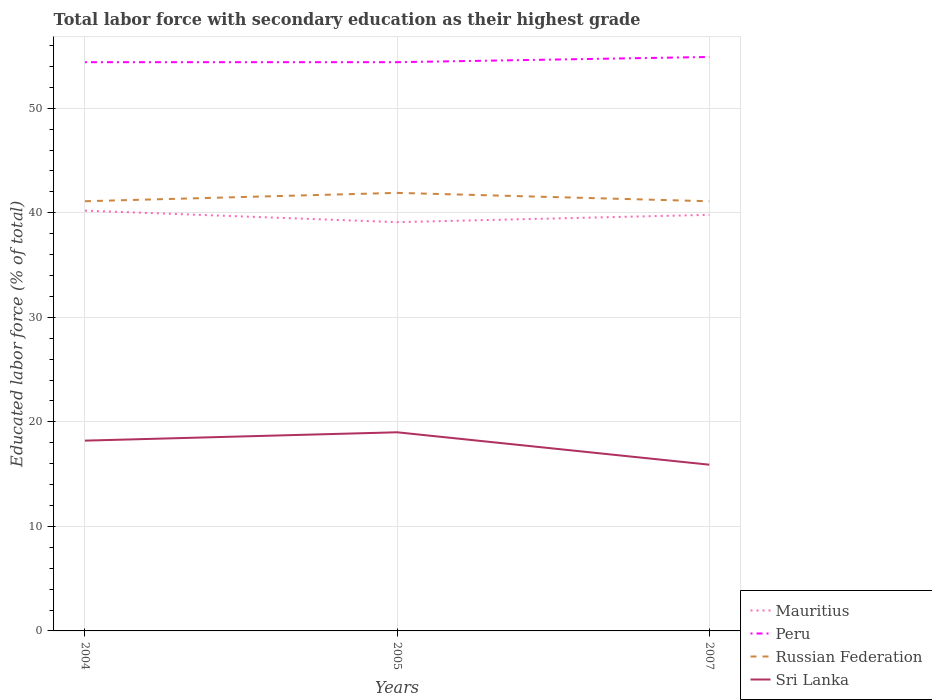Across all years, what is the maximum percentage of total labor force with primary education in Mauritius?
Your response must be concise. 39.1. In which year was the percentage of total labor force with primary education in Sri Lanka maximum?
Give a very brief answer. 2007. What is the total percentage of total labor force with primary education in Mauritius in the graph?
Your answer should be compact. 1.1. What is the difference between the highest and the second highest percentage of total labor force with primary education in Peru?
Your answer should be very brief. 0.5. What is the difference between the highest and the lowest percentage of total labor force with primary education in Peru?
Provide a short and direct response. 1. How many years are there in the graph?
Provide a succinct answer. 3. What is the difference between two consecutive major ticks on the Y-axis?
Offer a terse response. 10. Does the graph contain any zero values?
Give a very brief answer. No. How are the legend labels stacked?
Provide a short and direct response. Vertical. What is the title of the graph?
Provide a short and direct response. Total labor force with secondary education as their highest grade. What is the label or title of the X-axis?
Your answer should be compact. Years. What is the label or title of the Y-axis?
Your response must be concise. Educated labor force (% of total). What is the Educated labor force (% of total) of Mauritius in 2004?
Your response must be concise. 40.2. What is the Educated labor force (% of total) of Peru in 2004?
Your answer should be very brief. 54.4. What is the Educated labor force (% of total) of Russian Federation in 2004?
Give a very brief answer. 41.1. What is the Educated labor force (% of total) in Sri Lanka in 2004?
Provide a succinct answer. 18.2. What is the Educated labor force (% of total) of Mauritius in 2005?
Your response must be concise. 39.1. What is the Educated labor force (% of total) in Peru in 2005?
Your answer should be compact. 54.4. What is the Educated labor force (% of total) of Russian Federation in 2005?
Your answer should be very brief. 41.9. What is the Educated labor force (% of total) of Mauritius in 2007?
Make the answer very short. 39.8. What is the Educated labor force (% of total) of Peru in 2007?
Your response must be concise. 54.9. What is the Educated labor force (% of total) in Russian Federation in 2007?
Ensure brevity in your answer.  41.1. What is the Educated labor force (% of total) of Sri Lanka in 2007?
Offer a terse response. 15.9. Across all years, what is the maximum Educated labor force (% of total) of Mauritius?
Give a very brief answer. 40.2. Across all years, what is the maximum Educated labor force (% of total) of Peru?
Provide a succinct answer. 54.9. Across all years, what is the maximum Educated labor force (% of total) in Russian Federation?
Ensure brevity in your answer.  41.9. Across all years, what is the maximum Educated labor force (% of total) of Sri Lanka?
Your response must be concise. 19. Across all years, what is the minimum Educated labor force (% of total) of Mauritius?
Offer a terse response. 39.1. Across all years, what is the minimum Educated labor force (% of total) of Peru?
Provide a succinct answer. 54.4. Across all years, what is the minimum Educated labor force (% of total) of Russian Federation?
Ensure brevity in your answer.  41.1. Across all years, what is the minimum Educated labor force (% of total) in Sri Lanka?
Provide a succinct answer. 15.9. What is the total Educated labor force (% of total) of Mauritius in the graph?
Your answer should be compact. 119.1. What is the total Educated labor force (% of total) of Peru in the graph?
Your answer should be compact. 163.7. What is the total Educated labor force (% of total) of Russian Federation in the graph?
Provide a succinct answer. 124.1. What is the total Educated labor force (% of total) of Sri Lanka in the graph?
Your answer should be compact. 53.1. What is the difference between the Educated labor force (% of total) in Mauritius in 2004 and that in 2005?
Your response must be concise. 1.1. What is the difference between the Educated labor force (% of total) in Peru in 2004 and that in 2005?
Your answer should be compact. 0. What is the difference between the Educated labor force (% of total) of Sri Lanka in 2004 and that in 2005?
Your answer should be compact. -0.8. What is the difference between the Educated labor force (% of total) in Mauritius in 2005 and that in 2007?
Your answer should be compact. -0.7. What is the difference between the Educated labor force (% of total) in Sri Lanka in 2005 and that in 2007?
Your answer should be very brief. 3.1. What is the difference between the Educated labor force (% of total) of Mauritius in 2004 and the Educated labor force (% of total) of Sri Lanka in 2005?
Your answer should be very brief. 21.2. What is the difference between the Educated labor force (% of total) in Peru in 2004 and the Educated labor force (% of total) in Russian Federation in 2005?
Give a very brief answer. 12.5. What is the difference between the Educated labor force (% of total) of Peru in 2004 and the Educated labor force (% of total) of Sri Lanka in 2005?
Your response must be concise. 35.4. What is the difference between the Educated labor force (% of total) of Russian Federation in 2004 and the Educated labor force (% of total) of Sri Lanka in 2005?
Offer a terse response. 22.1. What is the difference between the Educated labor force (% of total) in Mauritius in 2004 and the Educated labor force (% of total) in Peru in 2007?
Ensure brevity in your answer.  -14.7. What is the difference between the Educated labor force (% of total) of Mauritius in 2004 and the Educated labor force (% of total) of Russian Federation in 2007?
Give a very brief answer. -0.9. What is the difference between the Educated labor force (% of total) in Mauritius in 2004 and the Educated labor force (% of total) in Sri Lanka in 2007?
Provide a short and direct response. 24.3. What is the difference between the Educated labor force (% of total) of Peru in 2004 and the Educated labor force (% of total) of Russian Federation in 2007?
Provide a succinct answer. 13.3. What is the difference between the Educated labor force (% of total) in Peru in 2004 and the Educated labor force (% of total) in Sri Lanka in 2007?
Your answer should be compact. 38.5. What is the difference between the Educated labor force (% of total) of Russian Federation in 2004 and the Educated labor force (% of total) of Sri Lanka in 2007?
Offer a very short reply. 25.2. What is the difference between the Educated labor force (% of total) of Mauritius in 2005 and the Educated labor force (% of total) of Peru in 2007?
Provide a succinct answer. -15.8. What is the difference between the Educated labor force (% of total) in Mauritius in 2005 and the Educated labor force (% of total) in Sri Lanka in 2007?
Provide a succinct answer. 23.2. What is the difference between the Educated labor force (% of total) in Peru in 2005 and the Educated labor force (% of total) in Sri Lanka in 2007?
Your response must be concise. 38.5. What is the average Educated labor force (% of total) of Mauritius per year?
Your answer should be compact. 39.7. What is the average Educated labor force (% of total) in Peru per year?
Make the answer very short. 54.57. What is the average Educated labor force (% of total) in Russian Federation per year?
Offer a terse response. 41.37. What is the average Educated labor force (% of total) in Sri Lanka per year?
Your response must be concise. 17.7. In the year 2004, what is the difference between the Educated labor force (% of total) in Mauritius and Educated labor force (% of total) in Peru?
Provide a short and direct response. -14.2. In the year 2004, what is the difference between the Educated labor force (% of total) in Peru and Educated labor force (% of total) in Russian Federation?
Ensure brevity in your answer.  13.3. In the year 2004, what is the difference between the Educated labor force (% of total) of Peru and Educated labor force (% of total) of Sri Lanka?
Keep it short and to the point. 36.2. In the year 2004, what is the difference between the Educated labor force (% of total) of Russian Federation and Educated labor force (% of total) of Sri Lanka?
Ensure brevity in your answer.  22.9. In the year 2005, what is the difference between the Educated labor force (% of total) in Mauritius and Educated labor force (% of total) in Peru?
Your answer should be compact. -15.3. In the year 2005, what is the difference between the Educated labor force (% of total) in Mauritius and Educated labor force (% of total) in Russian Federation?
Give a very brief answer. -2.8. In the year 2005, what is the difference between the Educated labor force (% of total) of Mauritius and Educated labor force (% of total) of Sri Lanka?
Provide a short and direct response. 20.1. In the year 2005, what is the difference between the Educated labor force (% of total) of Peru and Educated labor force (% of total) of Sri Lanka?
Provide a short and direct response. 35.4. In the year 2005, what is the difference between the Educated labor force (% of total) in Russian Federation and Educated labor force (% of total) in Sri Lanka?
Keep it short and to the point. 22.9. In the year 2007, what is the difference between the Educated labor force (% of total) of Mauritius and Educated labor force (% of total) of Peru?
Ensure brevity in your answer.  -15.1. In the year 2007, what is the difference between the Educated labor force (% of total) in Mauritius and Educated labor force (% of total) in Sri Lanka?
Keep it short and to the point. 23.9. In the year 2007, what is the difference between the Educated labor force (% of total) in Russian Federation and Educated labor force (% of total) in Sri Lanka?
Give a very brief answer. 25.2. What is the ratio of the Educated labor force (% of total) of Mauritius in 2004 to that in 2005?
Ensure brevity in your answer.  1.03. What is the ratio of the Educated labor force (% of total) of Peru in 2004 to that in 2005?
Your response must be concise. 1. What is the ratio of the Educated labor force (% of total) of Russian Federation in 2004 to that in 2005?
Ensure brevity in your answer.  0.98. What is the ratio of the Educated labor force (% of total) in Sri Lanka in 2004 to that in 2005?
Provide a succinct answer. 0.96. What is the ratio of the Educated labor force (% of total) in Mauritius in 2004 to that in 2007?
Provide a short and direct response. 1.01. What is the ratio of the Educated labor force (% of total) in Peru in 2004 to that in 2007?
Provide a short and direct response. 0.99. What is the ratio of the Educated labor force (% of total) of Russian Federation in 2004 to that in 2007?
Provide a short and direct response. 1. What is the ratio of the Educated labor force (% of total) in Sri Lanka in 2004 to that in 2007?
Your answer should be very brief. 1.14. What is the ratio of the Educated labor force (% of total) of Mauritius in 2005 to that in 2007?
Offer a terse response. 0.98. What is the ratio of the Educated labor force (% of total) in Peru in 2005 to that in 2007?
Ensure brevity in your answer.  0.99. What is the ratio of the Educated labor force (% of total) of Russian Federation in 2005 to that in 2007?
Ensure brevity in your answer.  1.02. What is the ratio of the Educated labor force (% of total) in Sri Lanka in 2005 to that in 2007?
Give a very brief answer. 1.2. What is the difference between the highest and the second highest Educated labor force (% of total) of Mauritius?
Your answer should be very brief. 0.4. What is the difference between the highest and the second highest Educated labor force (% of total) in Peru?
Provide a short and direct response. 0.5. What is the difference between the highest and the second highest Educated labor force (% of total) in Russian Federation?
Your answer should be very brief. 0.8. What is the difference between the highest and the lowest Educated labor force (% of total) in Mauritius?
Keep it short and to the point. 1.1. What is the difference between the highest and the lowest Educated labor force (% of total) in Peru?
Offer a terse response. 0.5. What is the difference between the highest and the lowest Educated labor force (% of total) of Russian Federation?
Ensure brevity in your answer.  0.8. 